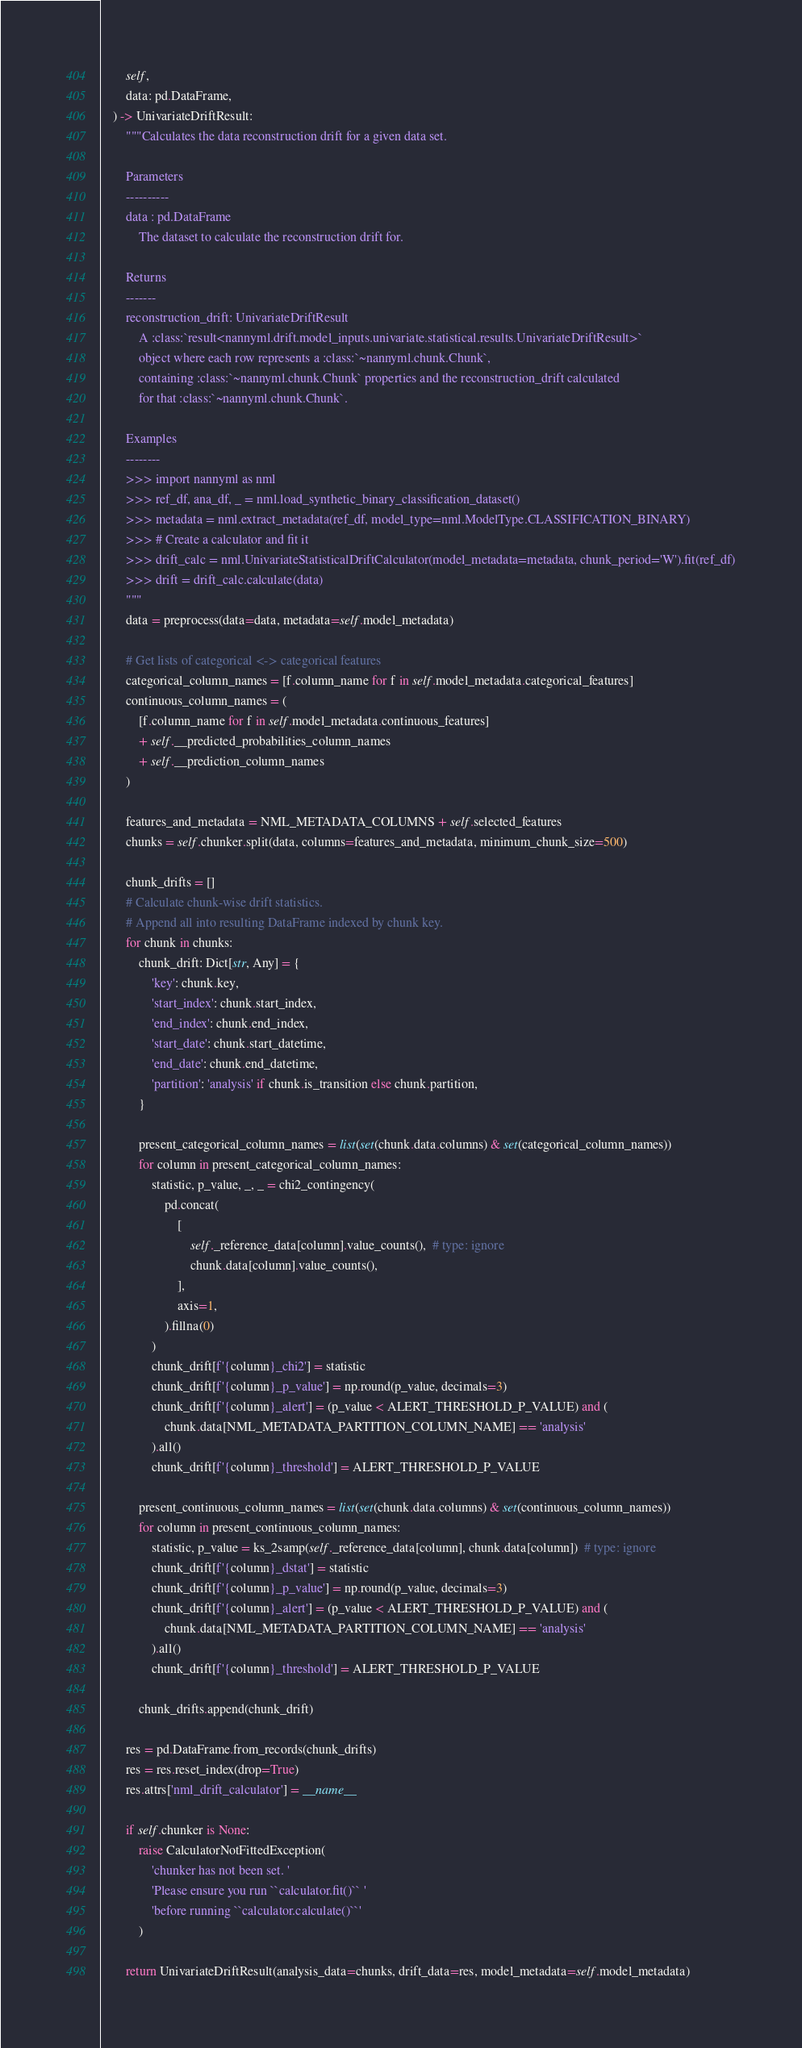<code> <loc_0><loc_0><loc_500><loc_500><_Python_>        self,
        data: pd.DataFrame,
    ) -> UnivariateDriftResult:
        """Calculates the data reconstruction drift for a given data set.

        Parameters
        ----------
        data : pd.DataFrame
            The dataset to calculate the reconstruction drift for.

        Returns
        -------
        reconstruction_drift: UnivariateDriftResult
            A :class:`result<nannyml.drift.model_inputs.univariate.statistical.results.UnivariateDriftResult>`
            object where each row represents a :class:`~nannyml.chunk.Chunk`,
            containing :class:`~nannyml.chunk.Chunk` properties and the reconstruction_drift calculated
            for that :class:`~nannyml.chunk.Chunk`.

        Examples
        --------
        >>> import nannyml as nml
        >>> ref_df, ana_df, _ = nml.load_synthetic_binary_classification_dataset()
        >>> metadata = nml.extract_metadata(ref_df, model_type=nml.ModelType.CLASSIFICATION_BINARY)
        >>> # Create a calculator and fit it
        >>> drift_calc = nml.UnivariateStatisticalDriftCalculator(model_metadata=metadata, chunk_period='W').fit(ref_df)
        >>> drift = drift_calc.calculate(data)
        """
        data = preprocess(data=data, metadata=self.model_metadata)

        # Get lists of categorical <-> categorical features
        categorical_column_names = [f.column_name for f in self.model_metadata.categorical_features]
        continuous_column_names = (
            [f.column_name for f in self.model_metadata.continuous_features]
            + self.__predicted_probabilities_column_names
            + self.__prediction_column_names
        )

        features_and_metadata = NML_METADATA_COLUMNS + self.selected_features
        chunks = self.chunker.split(data, columns=features_and_metadata, minimum_chunk_size=500)

        chunk_drifts = []
        # Calculate chunk-wise drift statistics.
        # Append all into resulting DataFrame indexed by chunk key.
        for chunk in chunks:
            chunk_drift: Dict[str, Any] = {
                'key': chunk.key,
                'start_index': chunk.start_index,
                'end_index': chunk.end_index,
                'start_date': chunk.start_datetime,
                'end_date': chunk.end_datetime,
                'partition': 'analysis' if chunk.is_transition else chunk.partition,
            }

            present_categorical_column_names = list(set(chunk.data.columns) & set(categorical_column_names))
            for column in present_categorical_column_names:
                statistic, p_value, _, _ = chi2_contingency(
                    pd.concat(
                        [
                            self._reference_data[column].value_counts(),  # type: ignore
                            chunk.data[column].value_counts(),
                        ],
                        axis=1,
                    ).fillna(0)
                )
                chunk_drift[f'{column}_chi2'] = statistic
                chunk_drift[f'{column}_p_value'] = np.round(p_value, decimals=3)
                chunk_drift[f'{column}_alert'] = (p_value < ALERT_THRESHOLD_P_VALUE) and (
                    chunk.data[NML_METADATA_PARTITION_COLUMN_NAME] == 'analysis'
                ).all()
                chunk_drift[f'{column}_threshold'] = ALERT_THRESHOLD_P_VALUE

            present_continuous_column_names = list(set(chunk.data.columns) & set(continuous_column_names))
            for column in present_continuous_column_names:
                statistic, p_value = ks_2samp(self._reference_data[column], chunk.data[column])  # type: ignore
                chunk_drift[f'{column}_dstat'] = statistic
                chunk_drift[f'{column}_p_value'] = np.round(p_value, decimals=3)
                chunk_drift[f'{column}_alert'] = (p_value < ALERT_THRESHOLD_P_VALUE) and (
                    chunk.data[NML_METADATA_PARTITION_COLUMN_NAME] == 'analysis'
                ).all()
                chunk_drift[f'{column}_threshold'] = ALERT_THRESHOLD_P_VALUE

            chunk_drifts.append(chunk_drift)

        res = pd.DataFrame.from_records(chunk_drifts)
        res = res.reset_index(drop=True)
        res.attrs['nml_drift_calculator'] = __name__

        if self.chunker is None:
            raise CalculatorNotFittedException(
                'chunker has not been set. '
                'Please ensure you run ``calculator.fit()`` '
                'before running ``calculator.calculate()``'
            )

        return UnivariateDriftResult(analysis_data=chunks, drift_data=res, model_metadata=self.model_metadata)
</code> 